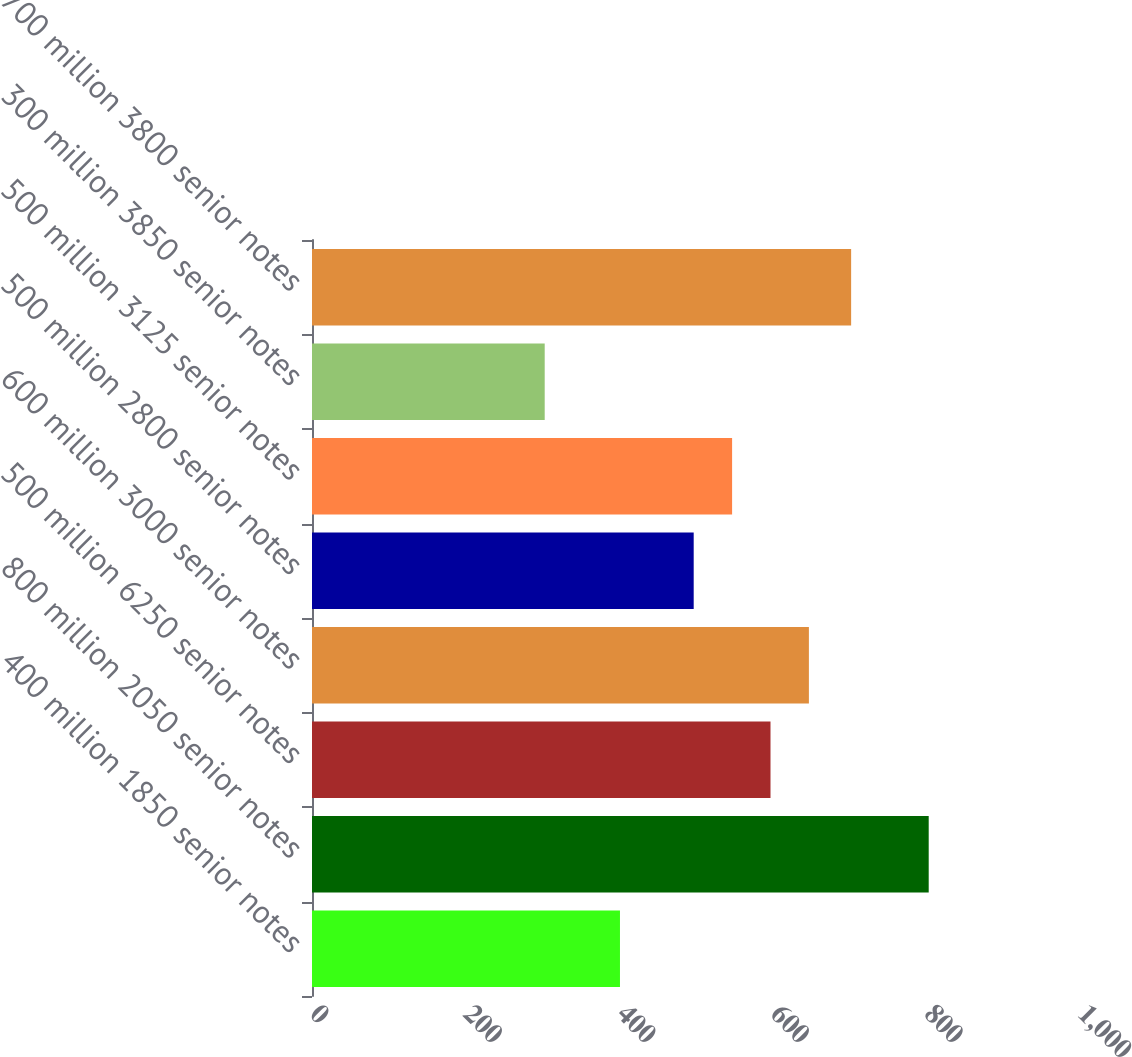Convert chart to OTSL. <chart><loc_0><loc_0><loc_500><loc_500><bar_chart><fcel>400 million 1850 senior notes<fcel>800 million 2050 senior notes<fcel>500 million 6250 senior notes<fcel>600 million 3000 senior notes<fcel>500 million 2800 senior notes<fcel>500 million 3125 senior notes<fcel>300 million 3850 senior notes<fcel>700 million 3800 senior notes<nl><fcel>401<fcel>803<fcel>597<fcel>647<fcel>497<fcel>547<fcel>303<fcel>702<nl></chart> 